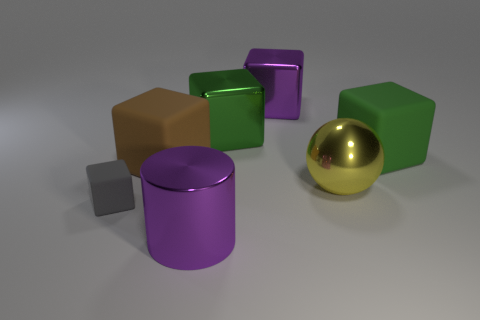What material is the brown thing?
Your answer should be compact. Rubber. There is a matte thing that is behind the big matte block left of the large metallic object that is in front of the big yellow sphere; what color is it?
Your response must be concise. Green. How many brown rubber blocks have the same size as the gray rubber block?
Provide a short and direct response. 0. There is a large block that is in front of the green rubber object; what is its color?
Offer a terse response. Brown. How many other things are the same size as the yellow sphere?
Your response must be concise. 5. What is the size of the cube that is both to the left of the purple metallic block and right of the brown object?
Make the answer very short. Large. Does the metallic sphere have the same color as the shiny thing in front of the small gray matte object?
Make the answer very short. No. Is there a large blue rubber object of the same shape as the tiny object?
Your answer should be very brief. No. How many objects are yellow cylinders or things that are to the right of the big brown rubber block?
Your answer should be compact. 5. How many other objects are there of the same material as the gray block?
Ensure brevity in your answer.  2. 